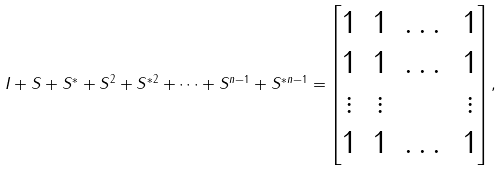Convert formula to latex. <formula><loc_0><loc_0><loc_500><loc_500>I + S + S ^ { * } + S ^ { 2 } + S ^ { * 2 } + \dots + S ^ { n - 1 } + S ^ { * n - 1 } = \begin{bmatrix} 1 & 1 & \dots & 1 \\ 1 & 1 & \dots & 1 \\ \vdots & \vdots & & \vdots \\ 1 & 1 & \dots & 1 \\ \end{bmatrix} ,</formula> 